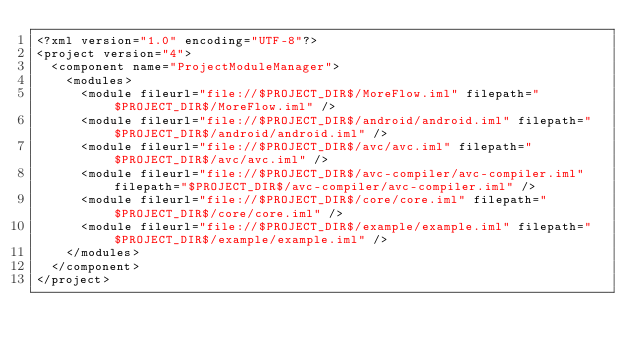<code> <loc_0><loc_0><loc_500><loc_500><_XML_><?xml version="1.0" encoding="UTF-8"?>
<project version="4">
  <component name="ProjectModuleManager">
    <modules>
      <module fileurl="file://$PROJECT_DIR$/MoreFlow.iml" filepath="$PROJECT_DIR$/MoreFlow.iml" />
      <module fileurl="file://$PROJECT_DIR$/android/android.iml" filepath="$PROJECT_DIR$/android/android.iml" />
      <module fileurl="file://$PROJECT_DIR$/avc/avc.iml" filepath="$PROJECT_DIR$/avc/avc.iml" />
      <module fileurl="file://$PROJECT_DIR$/avc-compiler/avc-compiler.iml" filepath="$PROJECT_DIR$/avc-compiler/avc-compiler.iml" />
      <module fileurl="file://$PROJECT_DIR$/core/core.iml" filepath="$PROJECT_DIR$/core/core.iml" />
      <module fileurl="file://$PROJECT_DIR$/example/example.iml" filepath="$PROJECT_DIR$/example/example.iml" />
    </modules>
  </component>
</project></code> 